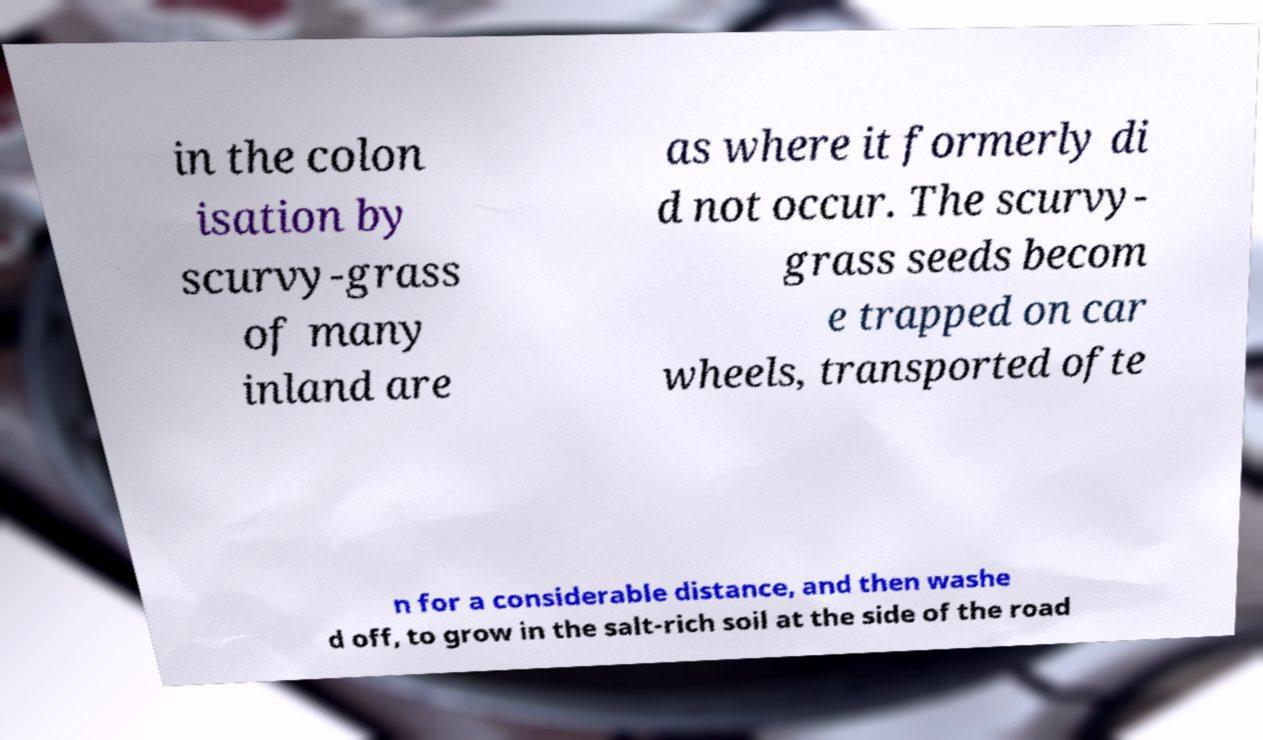Please read and relay the text visible in this image. What does it say? in the colon isation by scurvy-grass of many inland are as where it formerly di d not occur. The scurvy- grass seeds becom e trapped on car wheels, transported ofte n for a considerable distance, and then washe d off, to grow in the salt-rich soil at the side of the road 